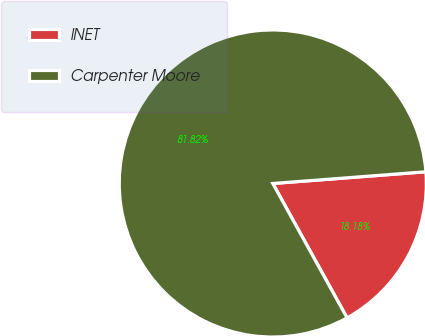Convert chart to OTSL. <chart><loc_0><loc_0><loc_500><loc_500><pie_chart><fcel>INET<fcel>Carpenter Moore<nl><fcel>18.18%<fcel>81.82%<nl></chart> 